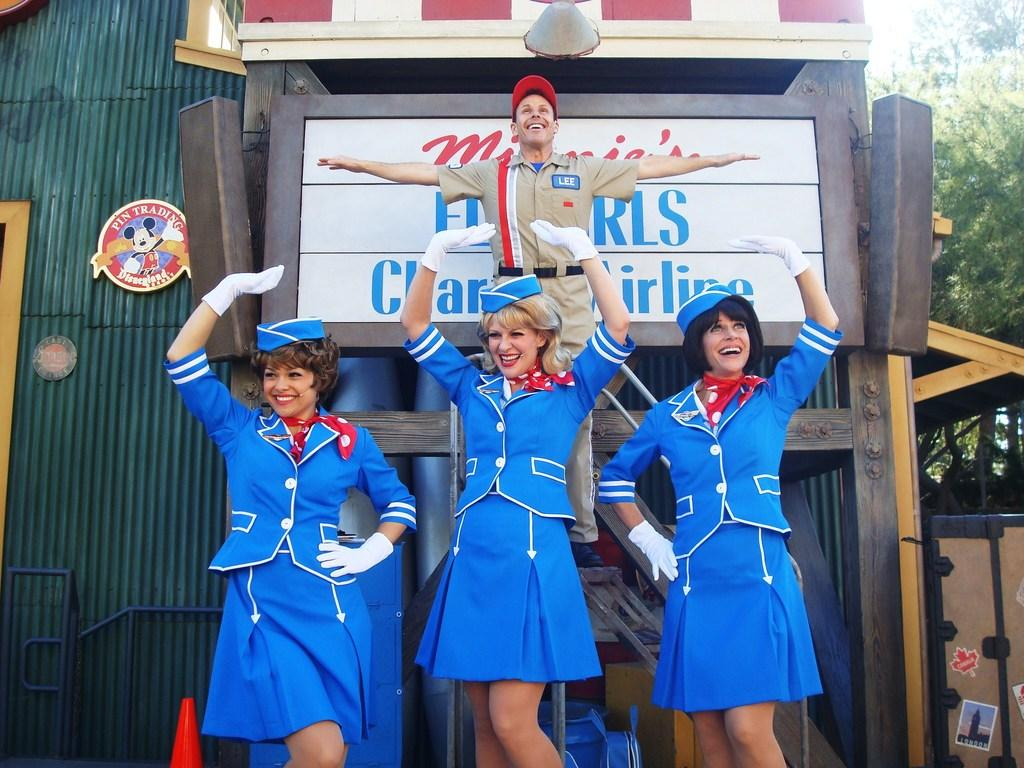<image>
Offer a succinct explanation of the picture presented. The girls are smiling while Lee is flying up above them. 